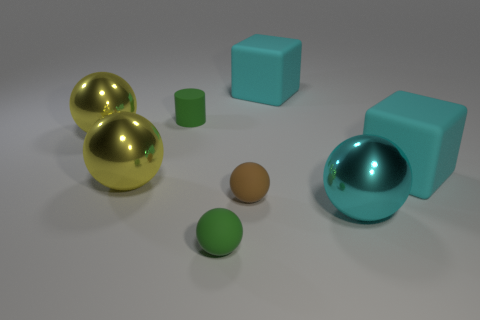There is a sphere that is to the left of the brown ball and in front of the brown matte object; what is its material? The sphere in question has a reflective surface which suggests that it's made of a material like polished metal or a coated substance with a high sheen, typically seen in metallic objects. 